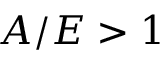<formula> <loc_0><loc_0><loc_500><loc_500>A / E > 1</formula> 